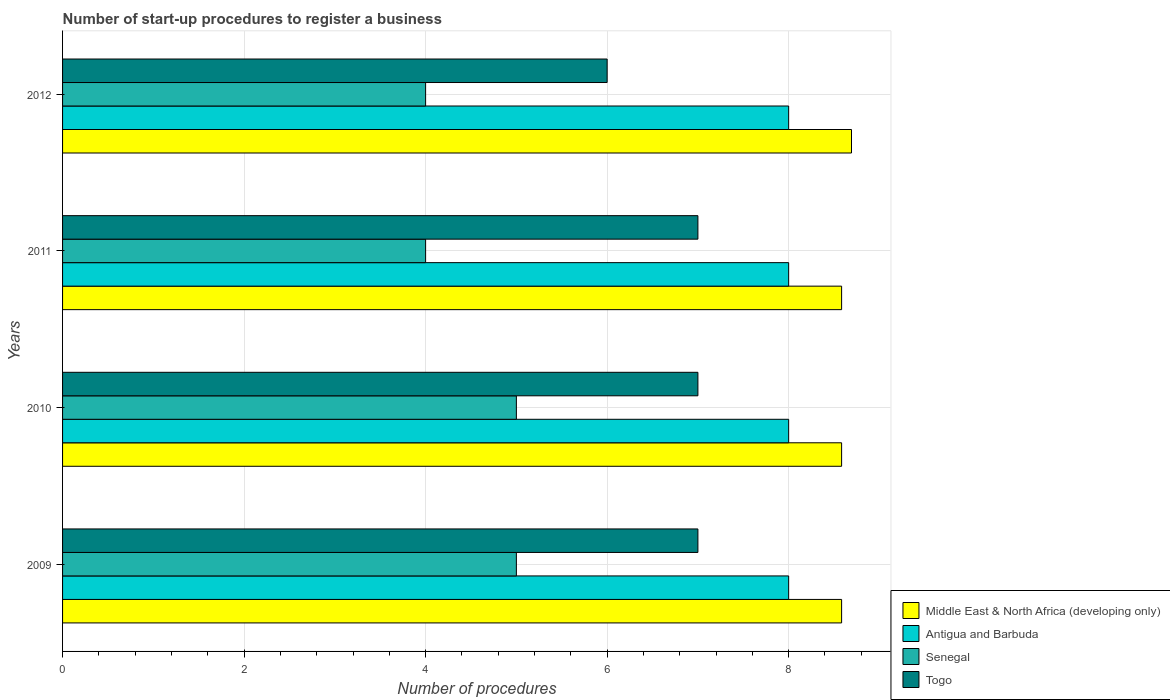How many groups of bars are there?
Your answer should be compact. 4. Are the number of bars per tick equal to the number of legend labels?
Your answer should be compact. Yes. Are the number of bars on each tick of the Y-axis equal?
Keep it short and to the point. Yes. How many bars are there on the 4th tick from the top?
Keep it short and to the point. 4. How many bars are there on the 4th tick from the bottom?
Offer a very short reply. 4. What is the label of the 3rd group of bars from the top?
Offer a very short reply. 2010. What is the number of procedures required to register a business in Middle East & North Africa (developing only) in 2009?
Offer a very short reply. 8.58. Across all years, what is the maximum number of procedures required to register a business in Middle East & North Africa (developing only)?
Provide a short and direct response. 8.69. What is the total number of procedures required to register a business in Senegal in the graph?
Provide a short and direct response. 18. What is the difference between the number of procedures required to register a business in Togo in 2011 and the number of procedures required to register a business in Middle East & North Africa (developing only) in 2012?
Your answer should be compact. -1.69. What is the average number of procedures required to register a business in Middle East & North Africa (developing only) per year?
Ensure brevity in your answer.  8.61. In the year 2009, what is the difference between the number of procedures required to register a business in Middle East & North Africa (developing only) and number of procedures required to register a business in Senegal?
Keep it short and to the point. 3.58. What is the ratio of the number of procedures required to register a business in Middle East & North Africa (developing only) in 2010 to that in 2012?
Provide a succinct answer. 0.99. Is the difference between the number of procedures required to register a business in Middle East & North Africa (developing only) in 2009 and 2012 greater than the difference between the number of procedures required to register a business in Senegal in 2009 and 2012?
Make the answer very short. No. What is the difference between the highest and the second highest number of procedures required to register a business in Middle East & North Africa (developing only)?
Offer a very short reply. 0.11. What is the difference between the highest and the lowest number of procedures required to register a business in Middle East & North Africa (developing only)?
Ensure brevity in your answer.  0.11. In how many years, is the number of procedures required to register a business in Senegal greater than the average number of procedures required to register a business in Senegal taken over all years?
Your answer should be compact. 2. Is it the case that in every year, the sum of the number of procedures required to register a business in Middle East & North Africa (developing only) and number of procedures required to register a business in Antigua and Barbuda is greater than the sum of number of procedures required to register a business in Togo and number of procedures required to register a business in Senegal?
Your answer should be compact. Yes. What does the 3rd bar from the top in 2011 represents?
Provide a short and direct response. Antigua and Barbuda. What does the 1st bar from the bottom in 2009 represents?
Offer a very short reply. Middle East & North Africa (developing only). Are all the bars in the graph horizontal?
Provide a succinct answer. Yes. How many years are there in the graph?
Offer a terse response. 4. Does the graph contain grids?
Make the answer very short. Yes. How many legend labels are there?
Provide a short and direct response. 4. How are the legend labels stacked?
Give a very brief answer. Vertical. What is the title of the graph?
Offer a terse response. Number of start-up procedures to register a business. What is the label or title of the X-axis?
Provide a short and direct response. Number of procedures. What is the label or title of the Y-axis?
Your response must be concise. Years. What is the Number of procedures of Middle East & North Africa (developing only) in 2009?
Offer a terse response. 8.58. What is the Number of procedures in Antigua and Barbuda in 2009?
Offer a very short reply. 8. What is the Number of procedures in Senegal in 2009?
Offer a terse response. 5. What is the Number of procedures in Togo in 2009?
Your answer should be very brief. 7. What is the Number of procedures in Middle East & North Africa (developing only) in 2010?
Keep it short and to the point. 8.58. What is the Number of procedures in Antigua and Barbuda in 2010?
Provide a succinct answer. 8. What is the Number of procedures in Middle East & North Africa (developing only) in 2011?
Make the answer very short. 8.58. What is the Number of procedures in Antigua and Barbuda in 2011?
Provide a short and direct response. 8. What is the Number of procedures of Togo in 2011?
Make the answer very short. 7. What is the Number of procedures of Middle East & North Africa (developing only) in 2012?
Your answer should be very brief. 8.69. What is the Number of procedures in Senegal in 2012?
Make the answer very short. 4. What is the Number of procedures of Togo in 2012?
Provide a short and direct response. 6. Across all years, what is the maximum Number of procedures in Middle East & North Africa (developing only)?
Give a very brief answer. 8.69. Across all years, what is the minimum Number of procedures of Middle East & North Africa (developing only)?
Ensure brevity in your answer.  8.58. Across all years, what is the minimum Number of procedures of Togo?
Provide a short and direct response. 6. What is the total Number of procedures of Middle East & North Africa (developing only) in the graph?
Ensure brevity in your answer.  34.44. What is the total Number of procedures in Antigua and Barbuda in the graph?
Offer a terse response. 32. What is the total Number of procedures of Senegal in the graph?
Give a very brief answer. 18. What is the total Number of procedures of Togo in the graph?
Provide a short and direct response. 27. What is the difference between the Number of procedures of Antigua and Barbuda in 2009 and that in 2010?
Make the answer very short. 0. What is the difference between the Number of procedures of Senegal in 2009 and that in 2010?
Make the answer very short. 0. What is the difference between the Number of procedures of Togo in 2009 and that in 2010?
Provide a short and direct response. 0. What is the difference between the Number of procedures of Middle East & North Africa (developing only) in 2009 and that in 2011?
Keep it short and to the point. 0. What is the difference between the Number of procedures in Togo in 2009 and that in 2011?
Provide a short and direct response. 0. What is the difference between the Number of procedures in Middle East & North Africa (developing only) in 2009 and that in 2012?
Offer a terse response. -0.11. What is the difference between the Number of procedures in Senegal in 2009 and that in 2012?
Your answer should be very brief. 1. What is the difference between the Number of procedures in Senegal in 2010 and that in 2011?
Provide a succinct answer. 1. What is the difference between the Number of procedures of Togo in 2010 and that in 2011?
Give a very brief answer. 0. What is the difference between the Number of procedures of Middle East & North Africa (developing only) in 2010 and that in 2012?
Provide a short and direct response. -0.11. What is the difference between the Number of procedures in Antigua and Barbuda in 2010 and that in 2012?
Keep it short and to the point. 0. What is the difference between the Number of procedures of Senegal in 2010 and that in 2012?
Keep it short and to the point. 1. What is the difference between the Number of procedures of Togo in 2010 and that in 2012?
Your answer should be very brief. 1. What is the difference between the Number of procedures of Middle East & North Africa (developing only) in 2011 and that in 2012?
Offer a very short reply. -0.11. What is the difference between the Number of procedures in Middle East & North Africa (developing only) in 2009 and the Number of procedures in Antigua and Barbuda in 2010?
Your answer should be very brief. 0.58. What is the difference between the Number of procedures in Middle East & North Africa (developing only) in 2009 and the Number of procedures in Senegal in 2010?
Make the answer very short. 3.58. What is the difference between the Number of procedures in Middle East & North Africa (developing only) in 2009 and the Number of procedures in Togo in 2010?
Ensure brevity in your answer.  1.58. What is the difference between the Number of procedures of Middle East & North Africa (developing only) in 2009 and the Number of procedures of Antigua and Barbuda in 2011?
Give a very brief answer. 0.58. What is the difference between the Number of procedures in Middle East & North Africa (developing only) in 2009 and the Number of procedures in Senegal in 2011?
Give a very brief answer. 4.58. What is the difference between the Number of procedures in Middle East & North Africa (developing only) in 2009 and the Number of procedures in Togo in 2011?
Offer a very short reply. 1.58. What is the difference between the Number of procedures of Middle East & North Africa (developing only) in 2009 and the Number of procedures of Antigua and Barbuda in 2012?
Offer a very short reply. 0.58. What is the difference between the Number of procedures of Middle East & North Africa (developing only) in 2009 and the Number of procedures of Senegal in 2012?
Offer a terse response. 4.58. What is the difference between the Number of procedures of Middle East & North Africa (developing only) in 2009 and the Number of procedures of Togo in 2012?
Your answer should be very brief. 2.58. What is the difference between the Number of procedures in Antigua and Barbuda in 2009 and the Number of procedures in Senegal in 2012?
Offer a terse response. 4. What is the difference between the Number of procedures of Antigua and Barbuda in 2009 and the Number of procedures of Togo in 2012?
Your answer should be compact. 2. What is the difference between the Number of procedures in Senegal in 2009 and the Number of procedures in Togo in 2012?
Provide a succinct answer. -1. What is the difference between the Number of procedures in Middle East & North Africa (developing only) in 2010 and the Number of procedures in Antigua and Barbuda in 2011?
Keep it short and to the point. 0.58. What is the difference between the Number of procedures of Middle East & North Africa (developing only) in 2010 and the Number of procedures of Senegal in 2011?
Offer a terse response. 4.58. What is the difference between the Number of procedures of Middle East & North Africa (developing only) in 2010 and the Number of procedures of Togo in 2011?
Offer a terse response. 1.58. What is the difference between the Number of procedures in Senegal in 2010 and the Number of procedures in Togo in 2011?
Offer a terse response. -2. What is the difference between the Number of procedures of Middle East & North Africa (developing only) in 2010 and the Number of procedures of Antigua and Barbuda in 2012?
Offer a terse response. 0.58. What is the difference between the Number of procedures of Middle East & North Africa (developing only) in 2010 and the Number of procedures of Senegal in 2012?
Your answer should be very brief. 4.58. What is the difference between the Number of procedures in Middle East & North Africa (developing only) in 2010 and the Number of procedures in Togo in 2012?
Offer a very short reply. 2.58. What is the difference between the Number of procedures of Antigua and Barbuda in 2010 and the Number of procedures of Senegal in 2012?
Give a very brief answer. 4. What is the difference between the Number of procedures of Senegal in 2010 and the Number of procedures of Togo in 2012?
Keep it short and to the point. -1. What is the difference between the Number of procedures in Middle East & North Africa (developing only) in 2011 and the Number of procedures in Antigua and Barbuda in 2012?
Make the answer very short. 0.58. What is the difference between the Number of procedures of Middle East & North Africa (developing only) in 2011 and the Number of procedures of Senegal in 2012?
Offer a terse response. 4.58. What is the difference between the Number of procedures of Middle East & North Africa (developing only) in 2011 and the Number of procedures of Togo in 2012?
Your answer should be very brief. 2.58. What is the difference between the Number of procedures of Antigua and Barbuda in 2011 and the Number of procedures of Togo in 2012?
Your answer should be very brief. 2. What is the average Number of procedures in Middle East & North Africa (developing only) per year?
Your answer should be very brief. 8.61. What is the average Number of procedures in Togo per year?
Make the answer very short. 6.75. In the year 2009, what is the difference between the Number of procedures of Middle East & North Africa (developing only) and Number of procedures of Antigua and Barbuda?
Your answer should be very brief. 0.58. In the year 2009, what is the difference between the Number of procedures of Middle East & North Africa (developing only) and Number of procedures of Senegal?
Provide a short and direct response. 3.58. In the year 2009, what is the difference between the Number of procedures of Middle East & North Africa (developing only) and Number of procedures of Togo?
Ensure brevity in your answer.  1.58. In the year 2010, what is the difference between the Number of procedures of Middle East & North Africa (developing only) and Number of procedures of Antigua and Barbuda?
Your response must be concise. 0.58. In the year 2010, what is the difference between the Number of procedures of Middle East & North Africa (developing only) and Number of procedures of Senegal?
Your response must be concise. 3.58. In the year 2010, what is the difference between the Number of procedures of Middle East & North Africa (developing only) and Number of procedures of Togo?
Your answer should be compact. 1.58. In the year 2010, what is the difference between the Number of procedures of Antigua and Barbuda and Number of procedures of Senegal?
Your answer should be very brief. 3. In the year 2010, what is the difference between the Number of procedures in Antigua and Barbuda and Number of procedures in Togo?
Give a very brief answer. 1. In the year 2010, what is the difference between the Number of procedures of Senegal and Number of procedures of Togo?
Your answer should be very brief. -2. In the year 2011, what is the difference between the Number of procedures of Middle East & North Africa (developing only) and Number of procedures of Antigua and Barbuda?
Ensure brevity in your answer.  0.58. In the year 2011, what is the difference between the Number of procedures of Middle East & North Africa (developing only) and Number of procedures of Senegal?
Give a very brief answer. 4.58. In the year 2011, what is the difference between the Number of procedures of Middle East & North Africa (developing only) and Number of procedures of Togo?
Provide a succinct answer. 1.58. In the year 2011, what is the difference between the Number of procedures of Antigua and Barbuda and Number of procedures of Senegal?
Your answer should be compact. 4. In the year 2012, what is the difference between the Number of procedures of Middle East & North Africa (developing only) and Number of procedures of Antigua and Barbuda?
Offer a terse response. 0.69. In the year 2012, what is the difference between the Number of procedures in Middle East & North Africa (developing only) and Number of procedures in Senegal?
Make the answer very short. 4.69. In the year 2012, what is the difference between the Number of procedures in Middle East & North Africa (developing only) and Number of procedures in Togo?
Make the answer very short. 2.69. In the year 2012, what is the difference between the Number of procedures in Senegal and Number of procedures in Togo?
Provide a succinct answer. -2. What is the ratio of the Number of procedures in Middle East & North Africa (developing only) in 2009 to that in 2010?
Make the answer very short. 1. What is the ratio of the Number of procedures of Antigua and Barbuda in 2009 to that in 2010?
Provide a succinct answer. 1. What is the ratio of the Number of procedures in Togo in 2009 to that in 2010?
Your response must be concise. 1. What is the ratio of the Number of procedures of Middle East & North Africa (developing only) in 2009 to that in 2012?
Your answer should be compact. 0.99. What is the ratio of the Number of procedures of Togo in 2009 to that in 2012?
Make the answer very short. 1.17. What is the ratio of the Number of procedures in Antigua and Barbuda in 2010 to that in 2011?
Keep it short and to the point. 1. What is the ratio of the Number of procedures in Senegal in 2010 to that in 2011?
Your answer should be very brief. 1.25. What is the ratio of the Number of procedures of Togo in 2010 to that in 2011?
Give a very brief answer. 1. What is the ratio of the Number of procedures of Middle East & North Africa (developing only) in 2010 to that in 2012?
Your response must be concise. 0.99. What is the ratio of the Number of procedures of Middle East & North Africa (developing only) in 2011 to that in 2012?
Offer a very short reply. 0.99. What is the ratio of the Number of procedures of Antigua and Barbuda in 2011 to that in 2012?
Your answer should be compact. 1. What is the ratio of the Number of procedures of Senegal in 2011 to that in 2012?
Your answer should be compact. 1. What is the difference between the highest and the second highest Number of procedures of Middle East & North Africa (developing only)?
Make the answer very short. 0.11. What is the difference between the highest and the second highest Number of procedures of Togo?
Your answer should be very brief. 0. What is the difference between the highest and the lowest Number of procedures in Middle East & North Africa (developing only)?
Give a very brief answer. 0.11. What is the difference between the highest and the lowest Number of procedures of Antigua and Barbuda?
Your response must be concise. 0. What is the difference between the highest and the lowest Number of procedures of Senegal?
Keep it short and to the point. 1. 